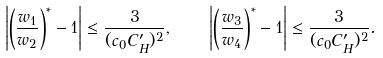<formula> <loc_0><loc_0><loc_500><loc_500>\left | \left ( \frac { w _ { 1 } } { w _ { 2 } } \right ) ^ { * } - 1 \right | \leq \frac { 3 } { ( c _ { 0 } C ^ { \prime } _ { H } ) ^ { 2 } } , \quad \left | \left ( \frac { w _ { 3 } } { w _ { 4 } } \right ) ^ { * } - 1 \right | \leq \frac { 3 } { ( c _ { 0 } C ^ { \prime } _ { H } ) ^ { 2 } } .</formula> 